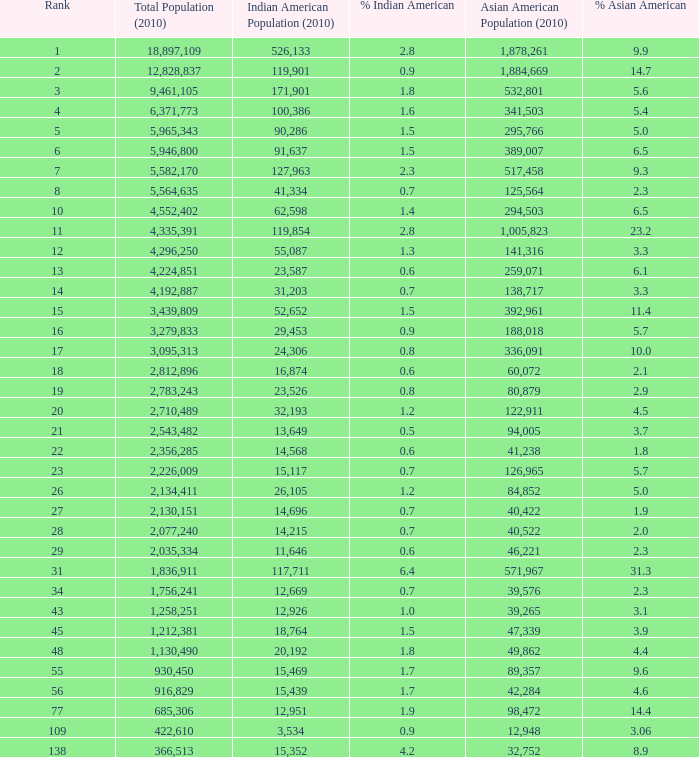2% indian american? 366513.0. 